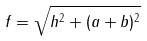<formula> <loc_0><loc_0><loc_500><loc_500>f = \sqrt { h ^ { 2 } + ( a + b ) ^ { 2 } }</formula> 